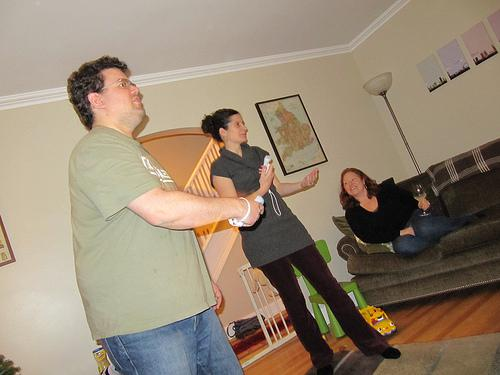Question: what is in the lady on left's hand?
Choices:
A. Wine glass.
B. Phone.
C. Sandwich.
D. Hot dog.
Answer with the letter. Answer: A Question: who is just watching the game play?
Choices:
A. Lady on couch.
B. Person in the chair.
C. Boy standing.
D. The Dad.
Answer with the letter. Answer: A Question: why are the people on the left standing?
Choices:
A. No more chairs.
B. They are playing a game.
C. They are excited.
D. Stretching their legs.
Answer with the letter. Answer: B Question: where is the man in the picture?
Choices:
A. Middle.
B. Left.
C. Right side.
D. Top.
Answer with the letter. Answer: C 